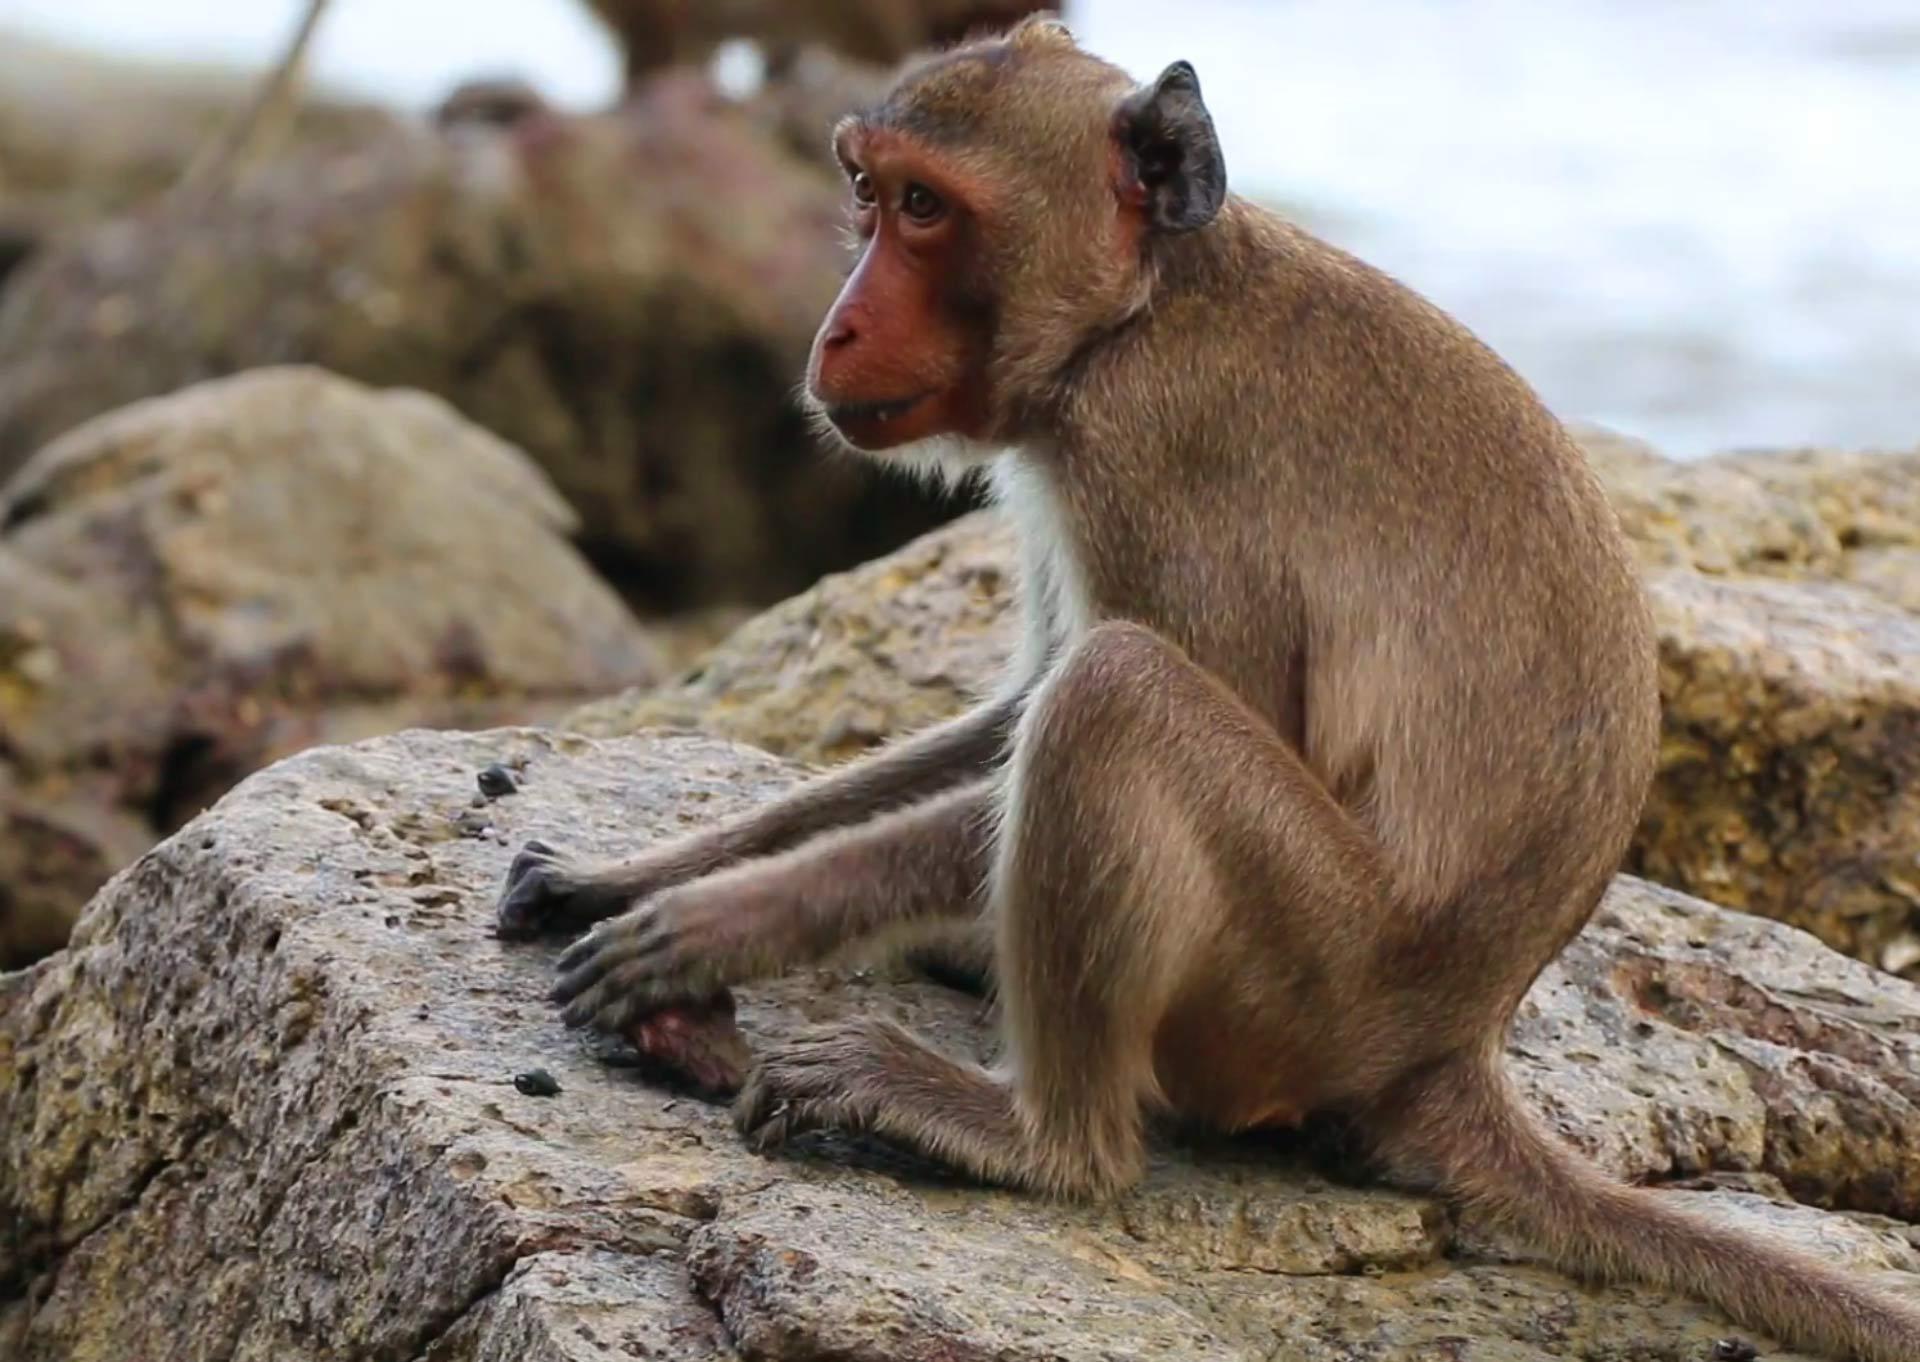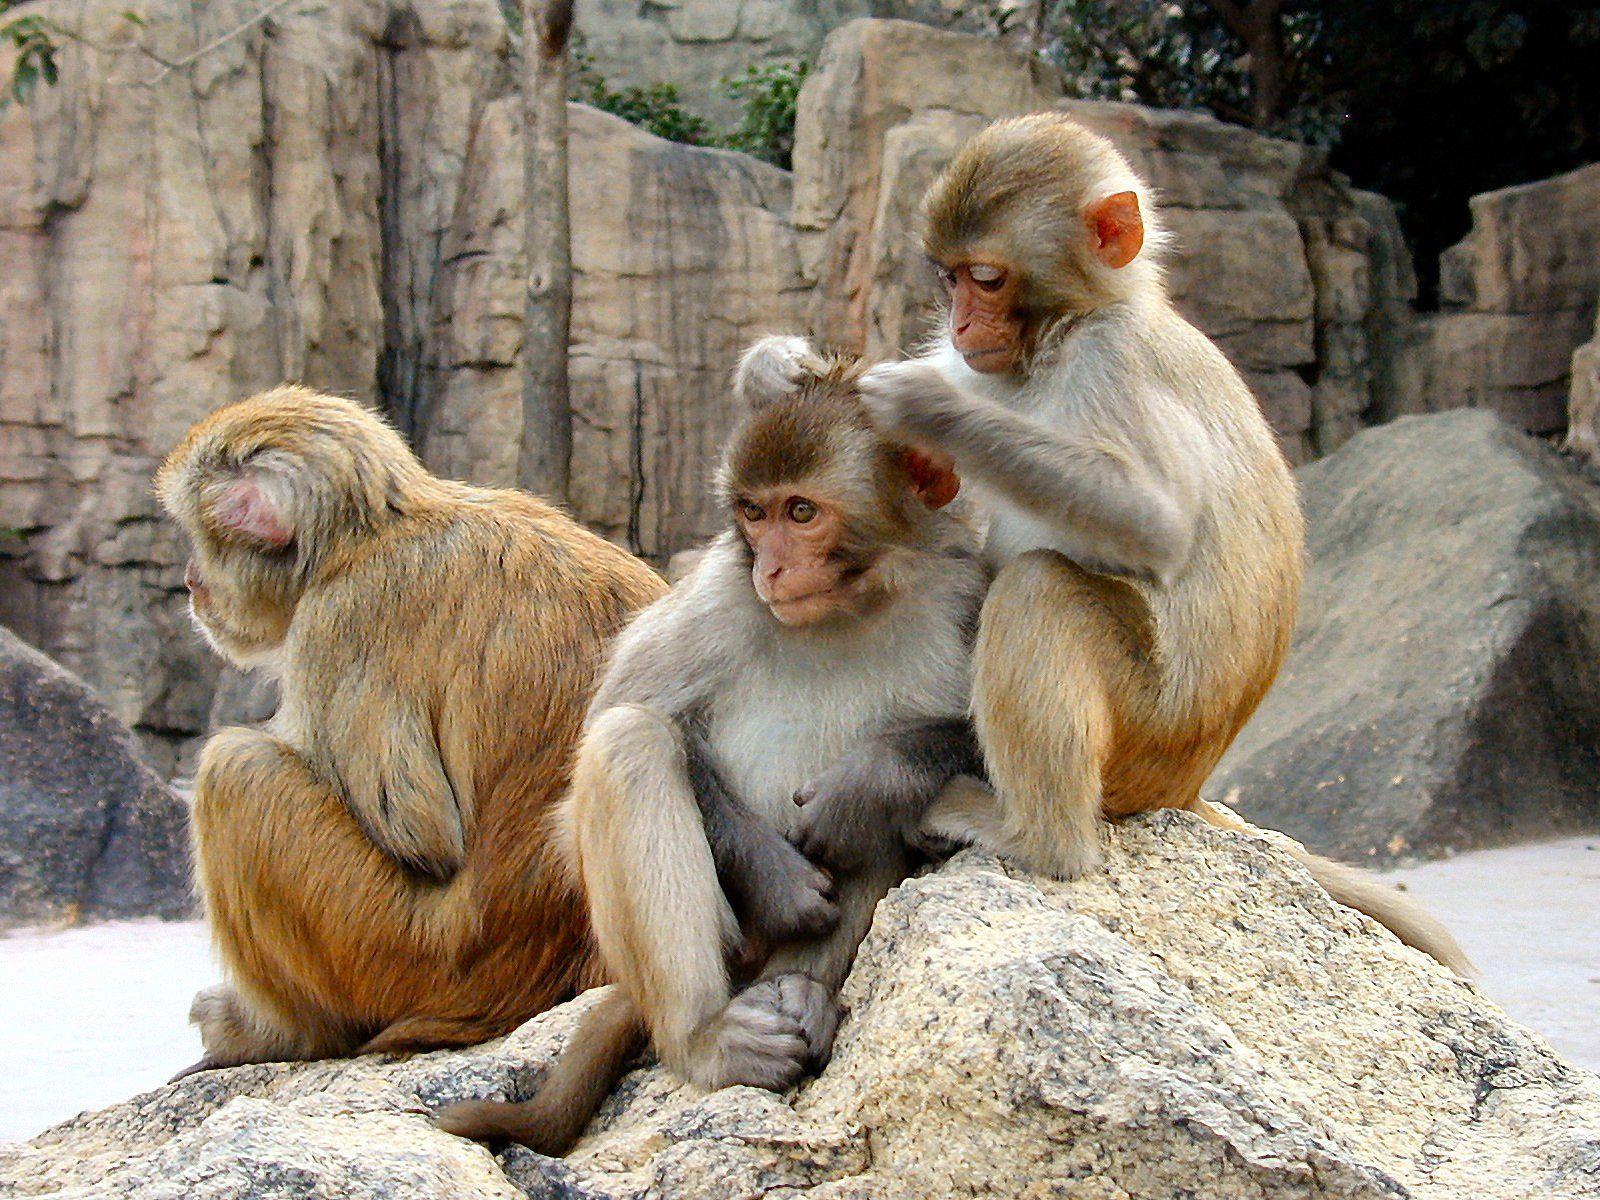The first image is the image on the left, the second image is the image on the right. Given the left and right images, does the statement "An image shows only a solitary monkey sitting on a rock." hold true? Answer yes or no. Yes. 